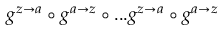Convert formula to latex. <formula><loc_0><loc_0><loc_500><loc_500>g ^ { z \rightarrow a } \circ g ^ { a \rightarrow z } \circ \dots g ^ { z \rightarrow a } \circ g ^ { a \rightarrow z }</formula> 